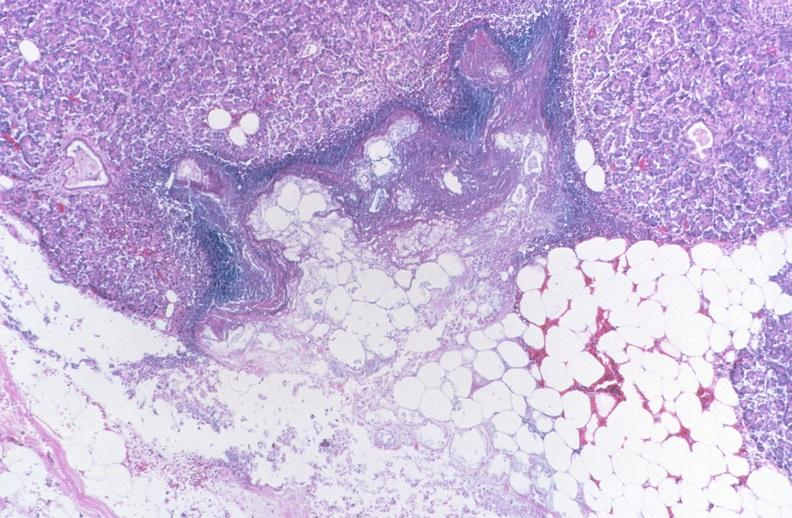does high excellent steroid show pancreatic fat necrosis, pancreatitis/necrosis?
Answer the question using a single word or phrase. No 